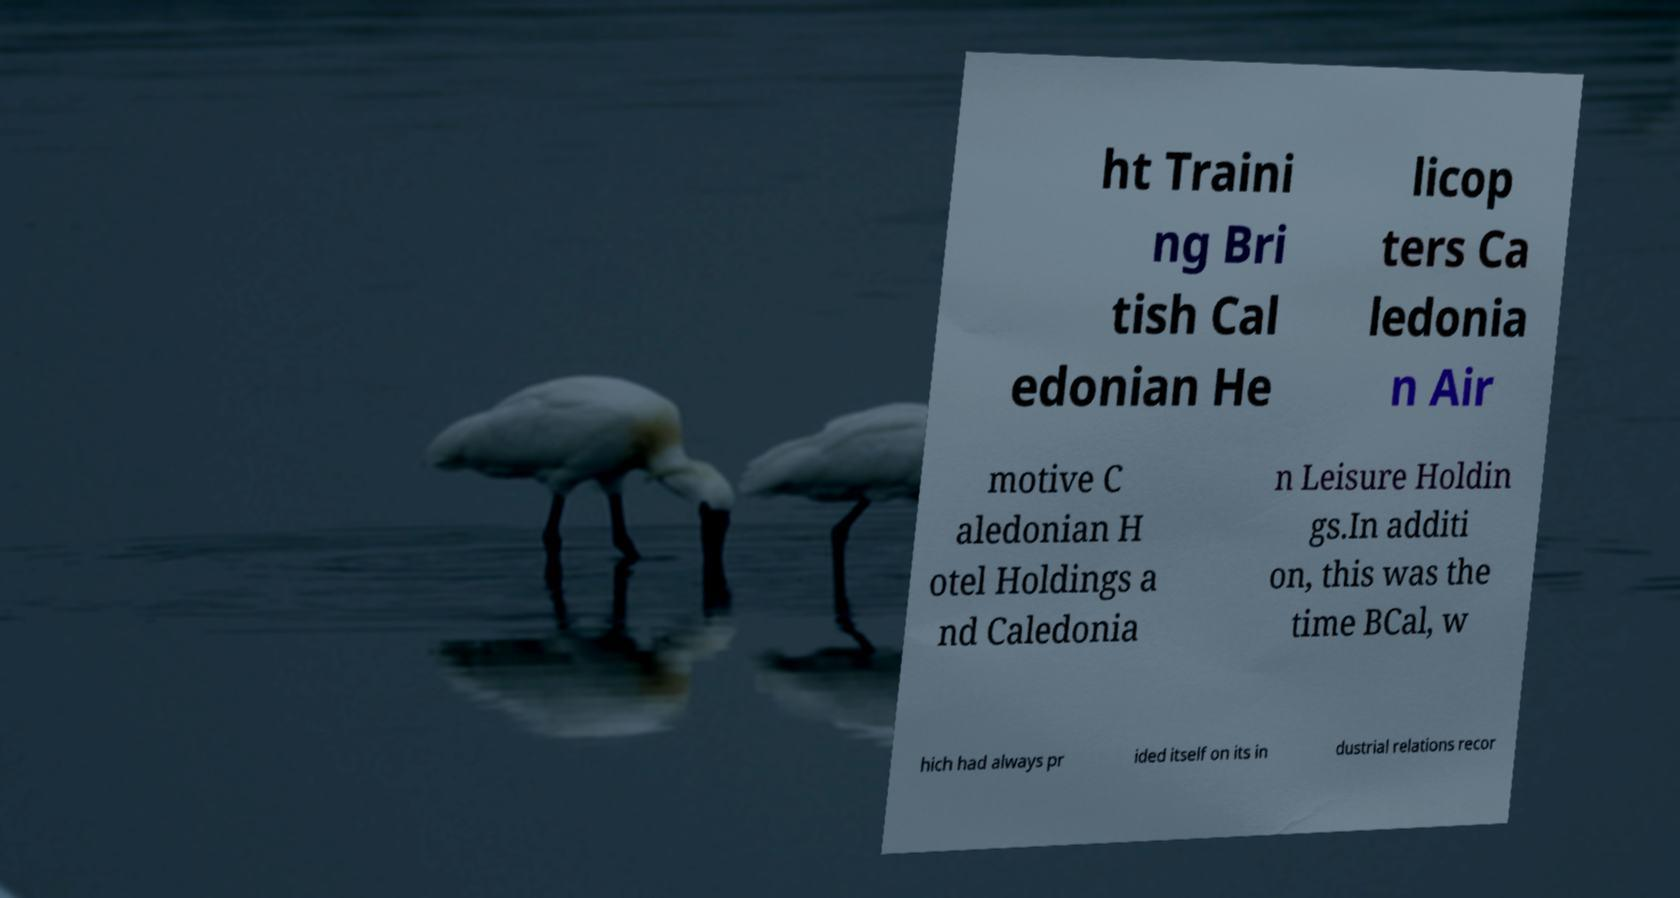Please identify and transcribe the text found in this image. ht Traini ng Bri tish Cal edonian He licop ters Ca ledonia n Air motive C aledonian H otel Holdings a nd Caledonia n Leisure Holdin gs.In additi on, this was the time BCal, w hich had always pr ided itself on its in dustrial relations recor 